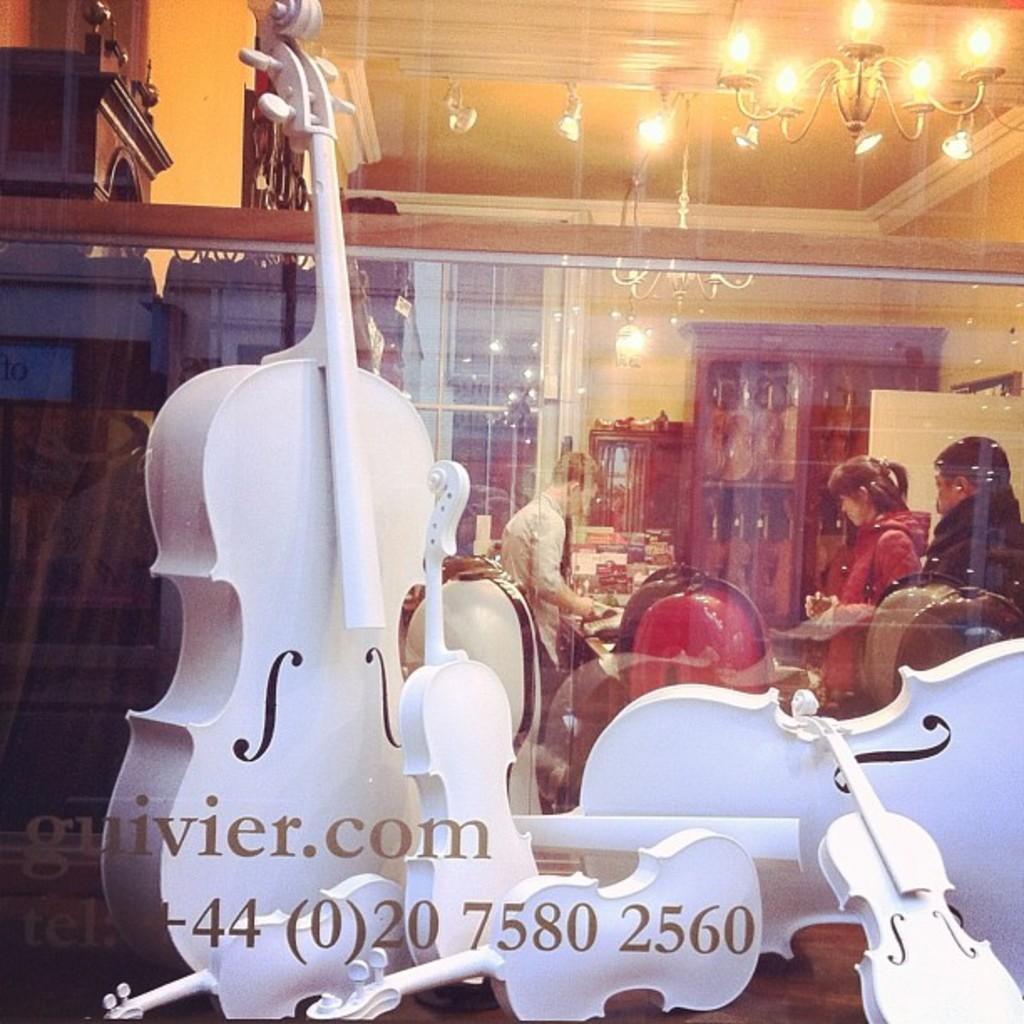Describe this image in one or two sentences. In this picture we can observe white color violins placed on the table. We can observe a glass. There is a watermark which is in brown color. We can observe three members standing. There is a cupboard in which some musical instruments were placed. We can observe chandelier on the right side. In the background there is a wall which is in yellow color. 